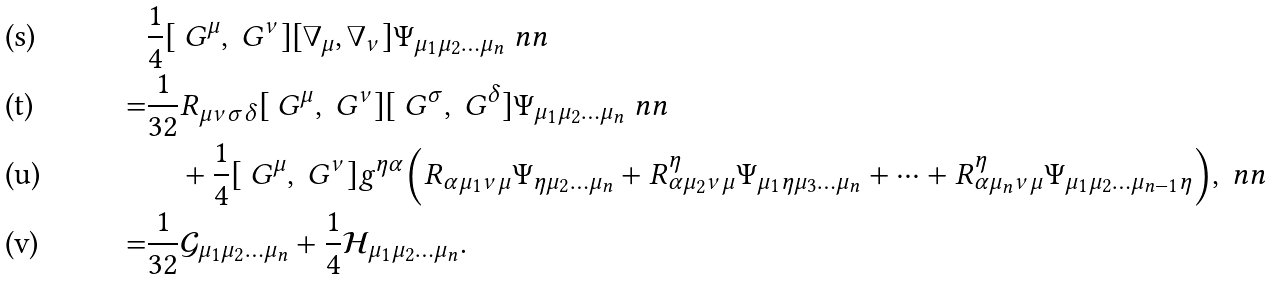Convert formula to latex. <formula><loc_0><loc_0><loc_500><loc_500>& \frac { 1 } { 4 } [ \ G ^ { \mu } , \ G ^ { \nu } ] [ \nabla _ { \mu } , \nabla _ { \nu } ] \Psi _ { \mu _ { 1 } \mu _ { 2 } \dots \mu _ { n } } \ n n \\ = & \frac { 1 } { 3 2 } R _ { \mu \nu \sigma \delta } [ \ G ^ { \mu } , \ G ^ { \nu } ] [ \ G ^ { \sigma } , \ G ^ { \delta } ] \Psi _ { \mu _ { 1 } \mu _ { 2 } \dots \mu _ { n } } \ n n \\ & \quad + \frac { 1 } { 4 } [ \ G ^ { \mu } , \ G ^ { \nu } ] g ^ { \eta \alpha } \Big { ( } R _ { \alpha \mu _ { 1 } \nu \mu } \Psi _ { \eta \mu _ { 2 } \dots \mu _ { n } } + R ^ { \eta } _ { \alpha \mu _ { 2 } \nu \mu } \Psi _ { \mu _ { 1 } \eta \mu _ { 3 } \dots \mu _ { n } } + \cdots + R ^ { \eta } _ { \alpha \mu _ { n } \nu \mu } \Psi _ { \mu _ { 1 } \mu _ { 2 } \dots \mu _ { n - 1 } \eta } \Big { ) } , \ n n \\ = & \frac { 1 } { 3 2 } \mathcal { G } _ { \mu _ { 1 } \mu _ { 2 } \dots \mu _ { n } } + \frac { 1 } { 4 } \mathcal { H } _ { \mu _ { 1 } \mu _ { 2 } \dots \mu _ { n } } .</formula> 